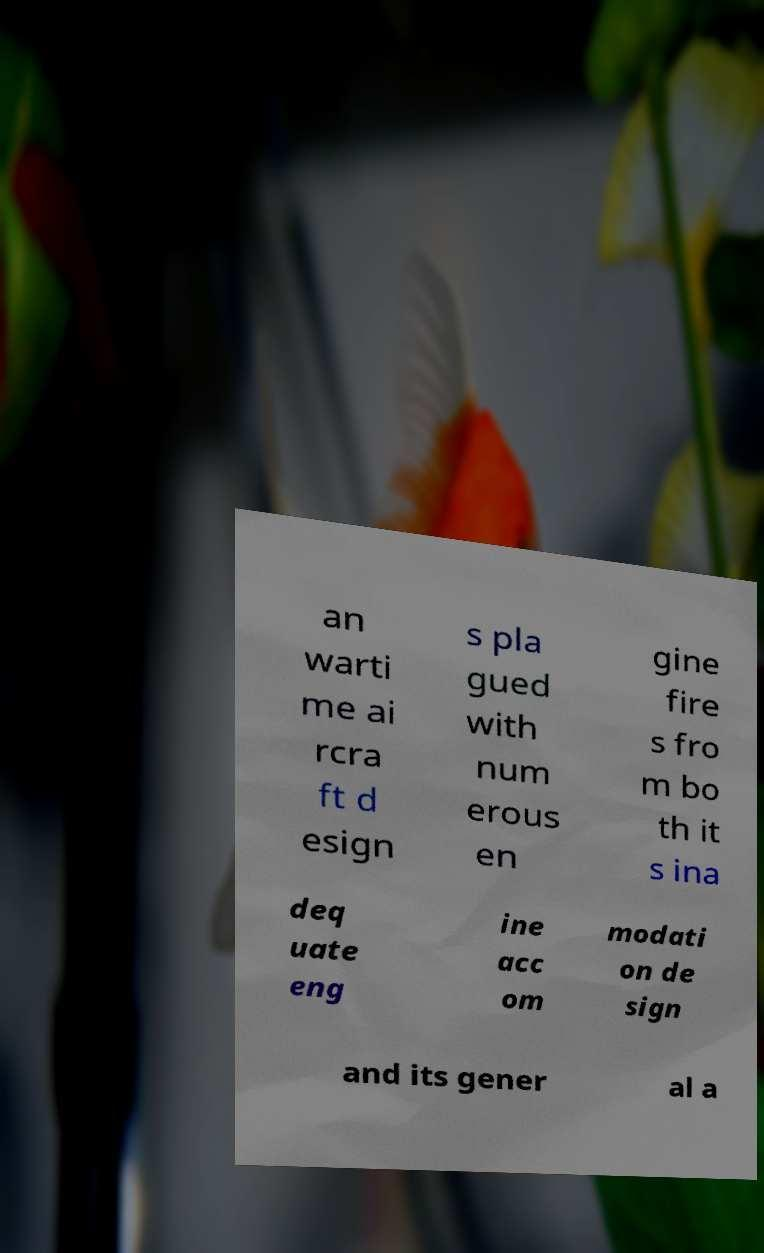Can you accurately transcribe the text from the provided image for me? an warti me ai rcra ft d esign s pla gued with num erous en gine fire s fro m bo th it s ina deq uate eng ine acc om modati on de sign and its gener al a 